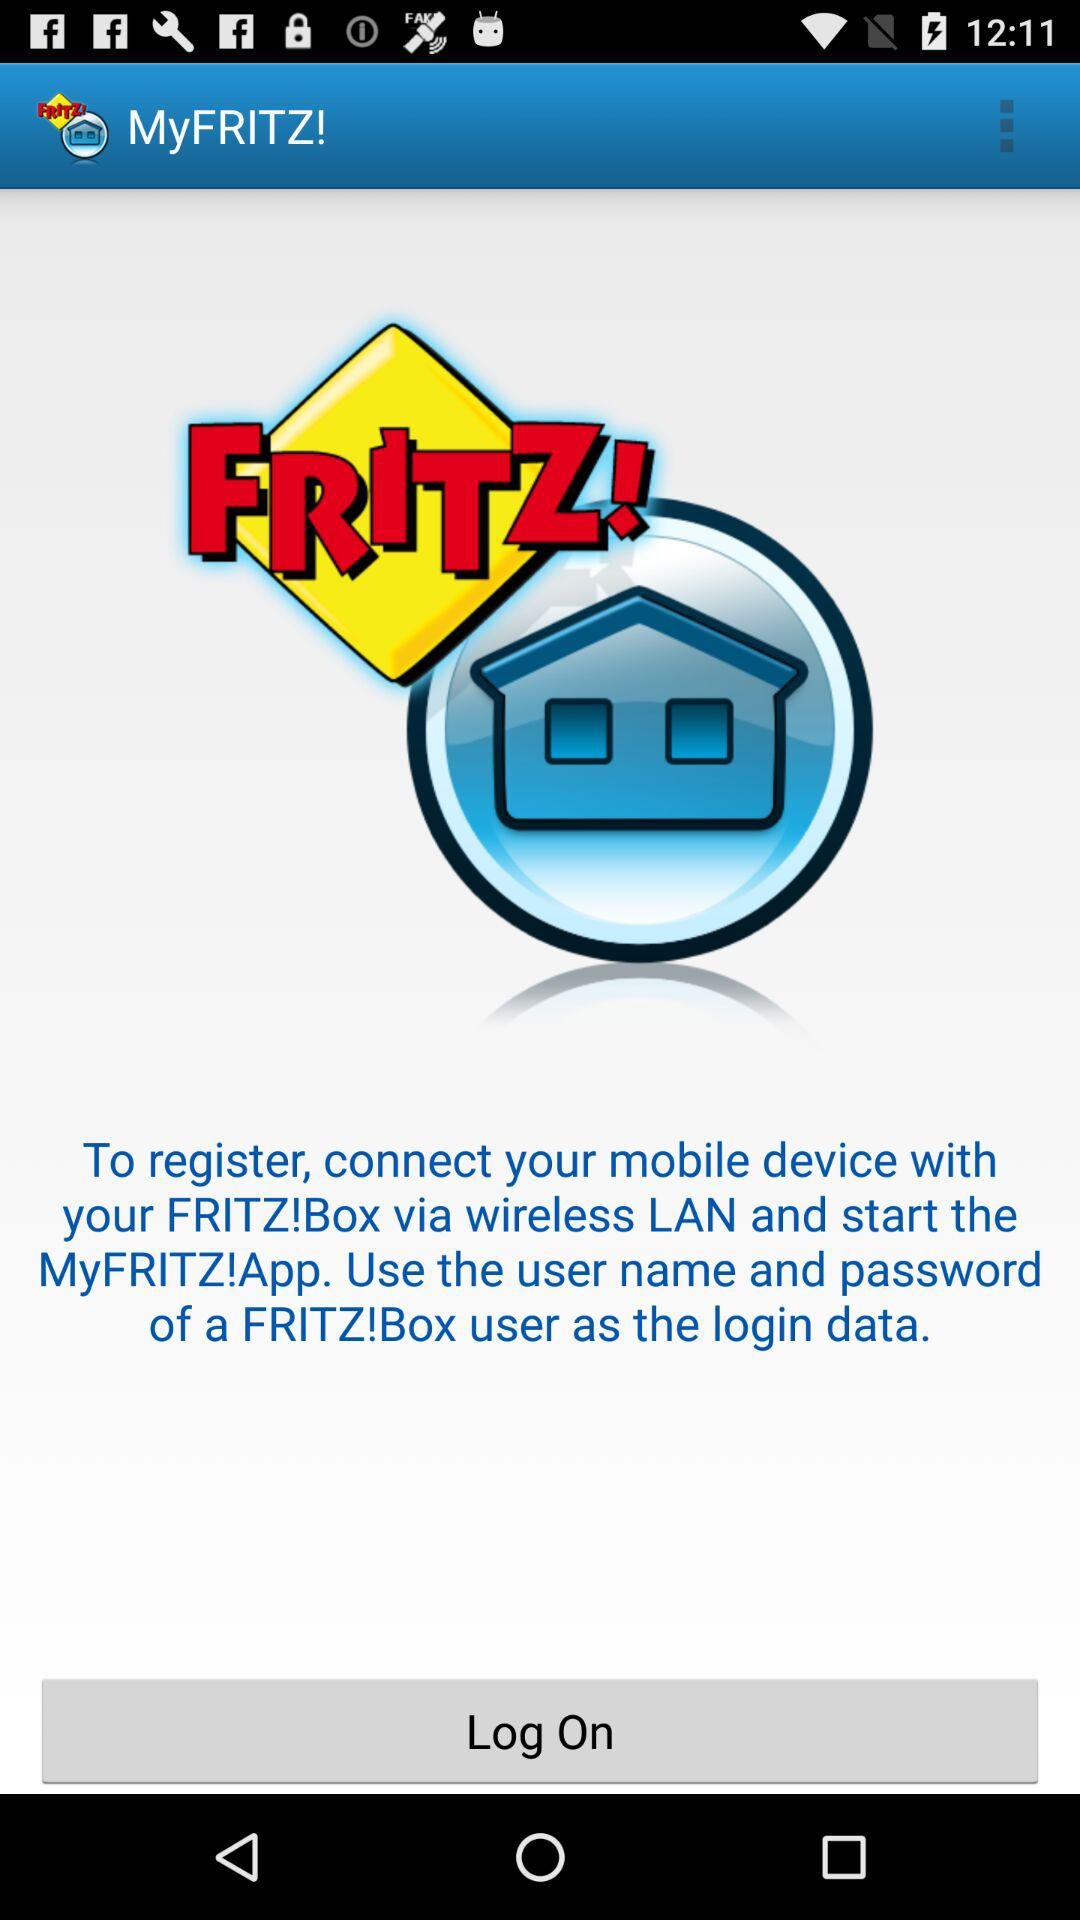What is the name of the application? The name of the application is "MyFRITZ!". 